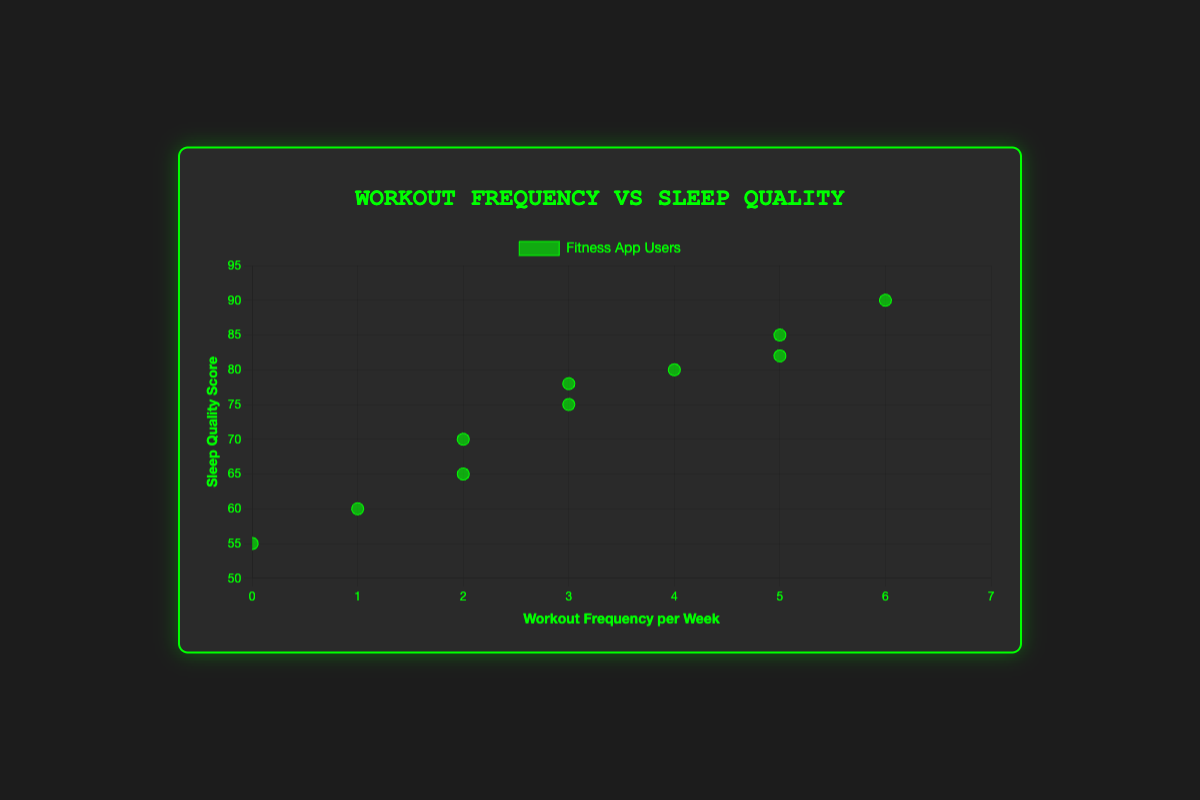What's the title of the figure? The title is usually located at the top of the figure and provides a summary of what the chart is about. In this case, it is "Workout Frequency vs Sleep Quality".
Answer: Workout Frequency vs Sleep Quality How many total data points are plotted on the scatter plot? Count each data point plotted on the scatter plot, where each point represents a user in the dataset. There are 10 users in the dataset, so there are 10 data points.
Answer: 10 What are the axes titles of the scatter plot? The titles of the axes provide information about what each axis represents. The x-axis is labeled "Workout Frequency per Week" and the y-axis is labeled "Sleep Quality Score".
Answer: Workout Frequency per Week, Sleep Quality Score Which user has the highest sleep quality score, and what is it? By examining the data points and identifying the one with the highest y-value, we see that User U006 has the highest sleep quality score of 90.
Answer: U006, 90 What is the sleep quality score for a user who works out 3 times a week? Identify the data points where the x-value equals 3 and find the corresponding y-values. Both users U001 and U008 work out 3 times a week with sleep quality scores of 75 and 78, respectively.
Answer: 75, 78 Which data point represents the user who does not work out at all? Look for the data point where the x-value (workout frequency) is 0. User U007 does not work out at all.
Answer: U007 What is the difference in sleep quality scores between the user who works out the most and the user who does not work out at all? The user who works out the most is U006 with a frequency of 6 times a week and a sleep quality score of 90. The user who does not work out at all is U007 with a sleep quality score of 55. The difference is 90 - 55 = 35.
Answer: 35 Compare the sleep quality scores of users who work out 2 times a week. What do you observe? Looking at the points with an x-value of 2, we see that U005 has a sleep quality score of 70 and U010 has a score of 65. Users who work out 2 times a week have sleep quality scores of 70 and 65, indicating slight variability in sleep quality even with the same workout frequency.
Answer: 70, 65 Calculate the average sleep quality score for users who work out 5 times a week. Identify the data points where the x-value is 5, which are U002 and U009 with sleep quality scores of 85 and 82 respectively. The average sleep quality score is (85 + 82) / 2 = 83.5.
Answer: 83.5 Is there a visible trend between workout frequency and sleep quality score? Examine the overall scatter plot for a pattern or trend. As the workout frequency increases, the sleep quality scores generally increase as well, suggesting a positive correlation.
Answer: Positive correlation 